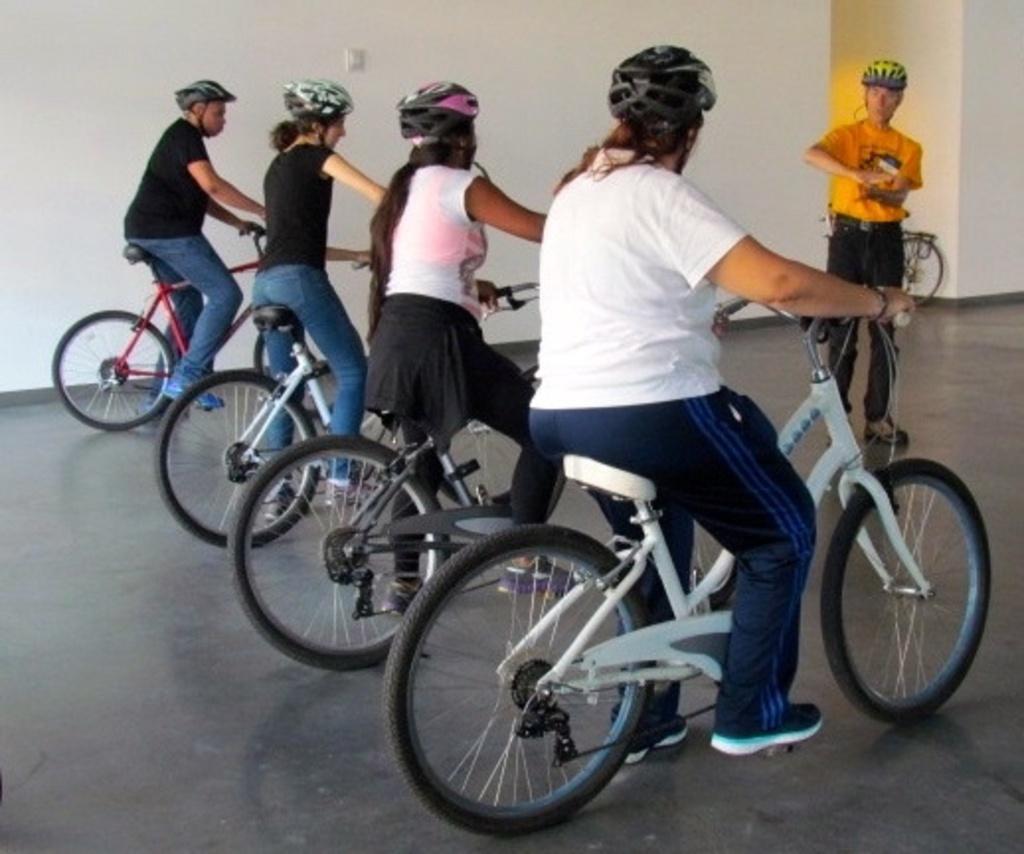Describe this image in one or two sentences. In this picture there are four people sitting on the bicycles stand a person in front of them. 